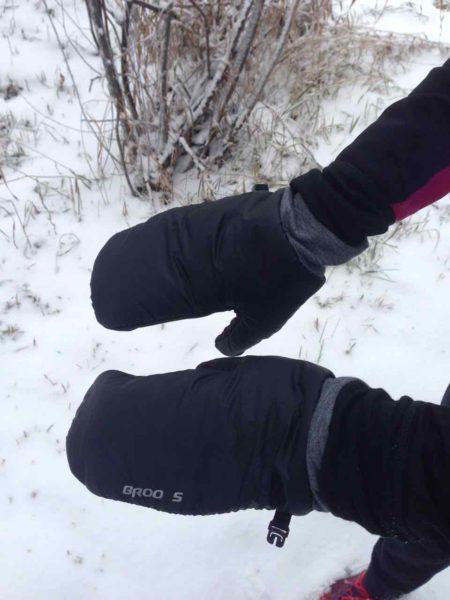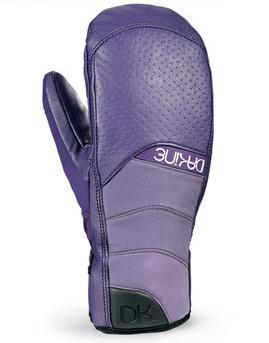The first image is the image on the left, the second image is the image on the right. For the images displayed, is the sentence "The pair of gloves on the right is at least mostly red in color." factually correct? Answer yes or no. No. The first image is the image on the left, the second image is the image on the right. Considering the images on both sides, is "Images each show one pair of mittens, and the mitten pairs are the same length." valid? Answer yes or no. No. 